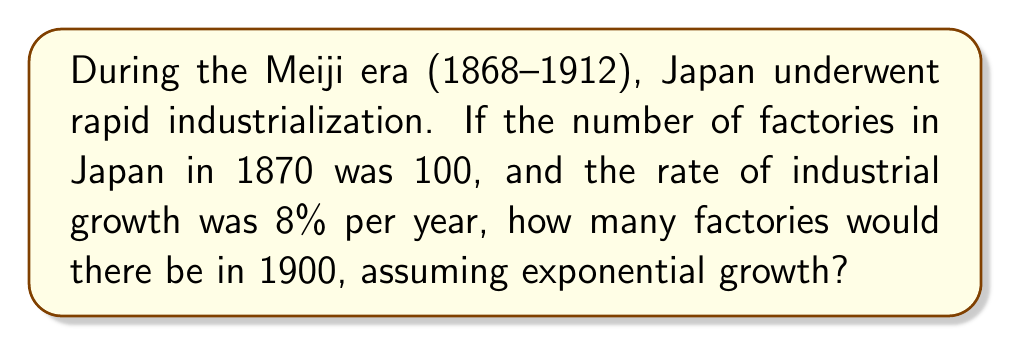Could you help me with this problem? To solve this problem, we'll use the exponential growth model:

$$ A = P(1 + r)^t $$

Where:
$A$ = final amount
$P$ = initial amount (100 factories)
$r$ = growth rate (8% = 0.08)
$t$ = time period (1900 - 1870 = 30 years)

Let's plug in the values:

$$ A = 100(1 + 0.08)^{30} $$

Now, we can calculate this step-by-step:

1) First, calculate $(1 + 0.08)$:
   $1 + 0.08 = 1.08$

2) Now, we need to calculate $1.08^{30}$:
   $1.08^{30} \approx 10.0627$

3) Finally, multiply by the initial amount:
   $100 \times 10.0627 \approx 1006.27$

Therefore, after 30 years of 8% annual growth, there would be approximately 1,006 factories in 1900.
Answer: 1,006 factories 